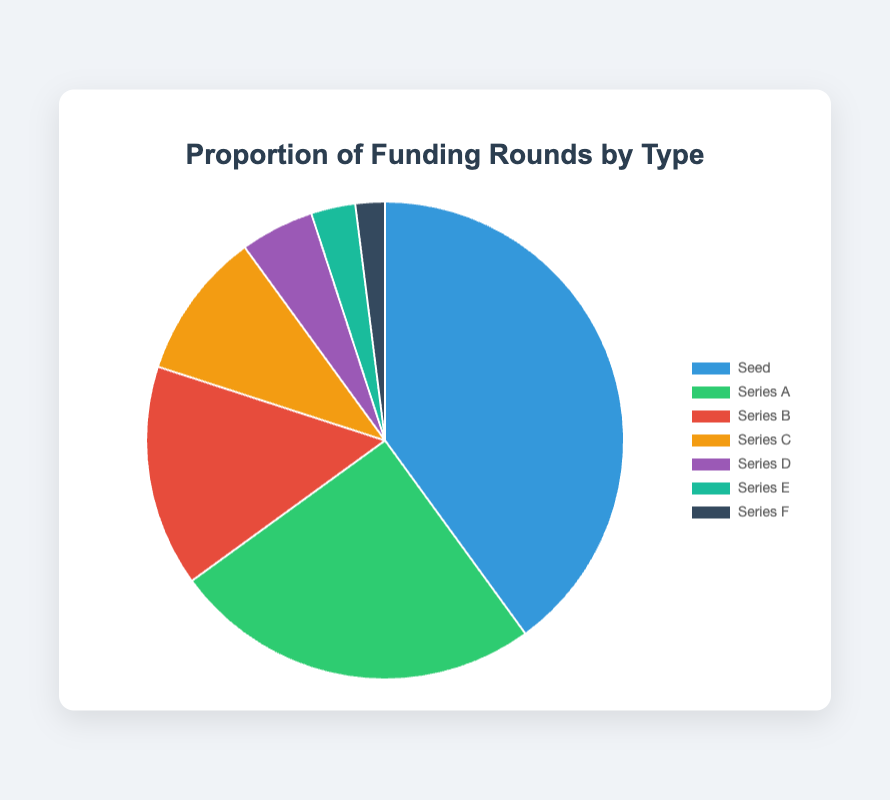Which funding round type has the highest proportion? The largest segment of the pie chart represents the funding round with the highest proportion, which is labeled 'Seed' with 40%.
Answer: Seed What is the combined proportion of Series C, Series D, and Series E funding rounds? Add the proportions for Series C (10%), Series D (5%), and Series E (3%). The combined proportion is 10% + 5% + 3% = 18%.
Answer: 18% Is the proportion of Seed funding rounds greater than the combined proportion of Series A and Series B funding rounds? The proportion for Seed rounds is 40%. The combined proportion for Series A and Series B is 25% + 15% = 40%. Since 40% is equal to 40%, the Seed proportion is not greater but equal to the combined Series A and Series B.
Answer: No, it's equal Which funding round type has the lowest proportion? The smallest segment of the pie chart represents the funding round with the lowest proportion, which is labeled 'Series F' with 2%.
Answer: Series F What is the average proportion of Series A and Series B funding rounds? The average of Series A (25%) and Series B (15%) is calculated as (25% + 15%) / 2 = 40% / 2 = 20%.
Answer: 20% Is the proportion of Series A funding rounds less than twice the proportion of Series B funding rounds? The proportion of Series A is 25%, and twice the proportion of Series B is 2 * 15% = 30%. Since 25% is less than 30%, the proportion of Series A is indeed less than twice that of Series B.
Answer: Yes How much larger is the proportion of Seed funding rounds compared to Series D funding rounds? The proportion of Seed rounds is 40%, and Series D rounds are 5%. The difference is 40% - 5% = 35%.
Answer: 35% What is the proportion of funding rounds that are not Seed or Series A? The total proportion of Seed and Series A rounds is 40% + 25% = 65%. The proportion not in Seed or Series A is 100% - 65% = 35%.
Answer: 35% What is the visual color representation of Series C funding rounds on the pie chart? The slice corresponding to Series C funding rounds is visually represented by the color that is fourth in the order, typically shown as 'orange' in the provided color palette.
Answer: Yellow Which funding round type has a proportion closest to the average of all funding rounds? The average proportion of all funding rounds is (40% + 25% + 15% + 10% + 5% + 3% + 2%) / 7 = 100% / 7 ≈ 14.29%. The proportion closest to this average is Series B, which has 15%.
Answer: Series B 